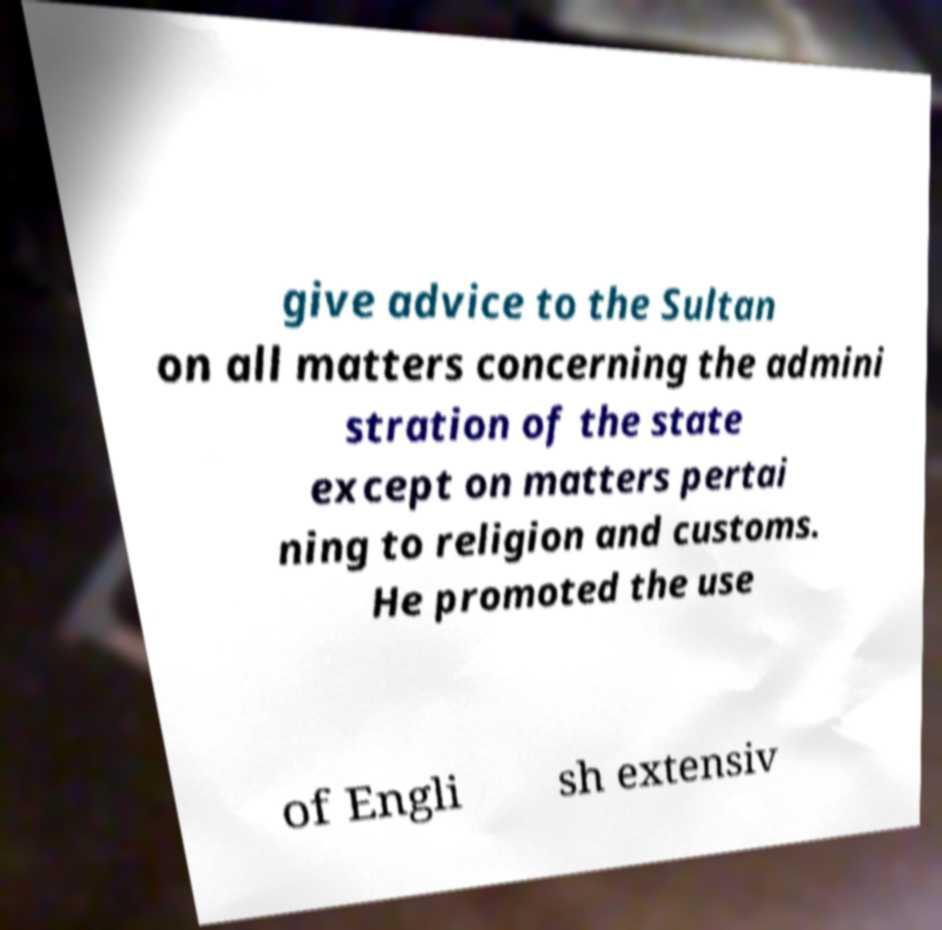What messages or text are displayed in this image? I need them in a readable, typed format. give advice to the Sultan on all matters concerning the admini stration of the state except on matters pertai ning to religion and customs. He promoted the use of Engli sh extensiv 